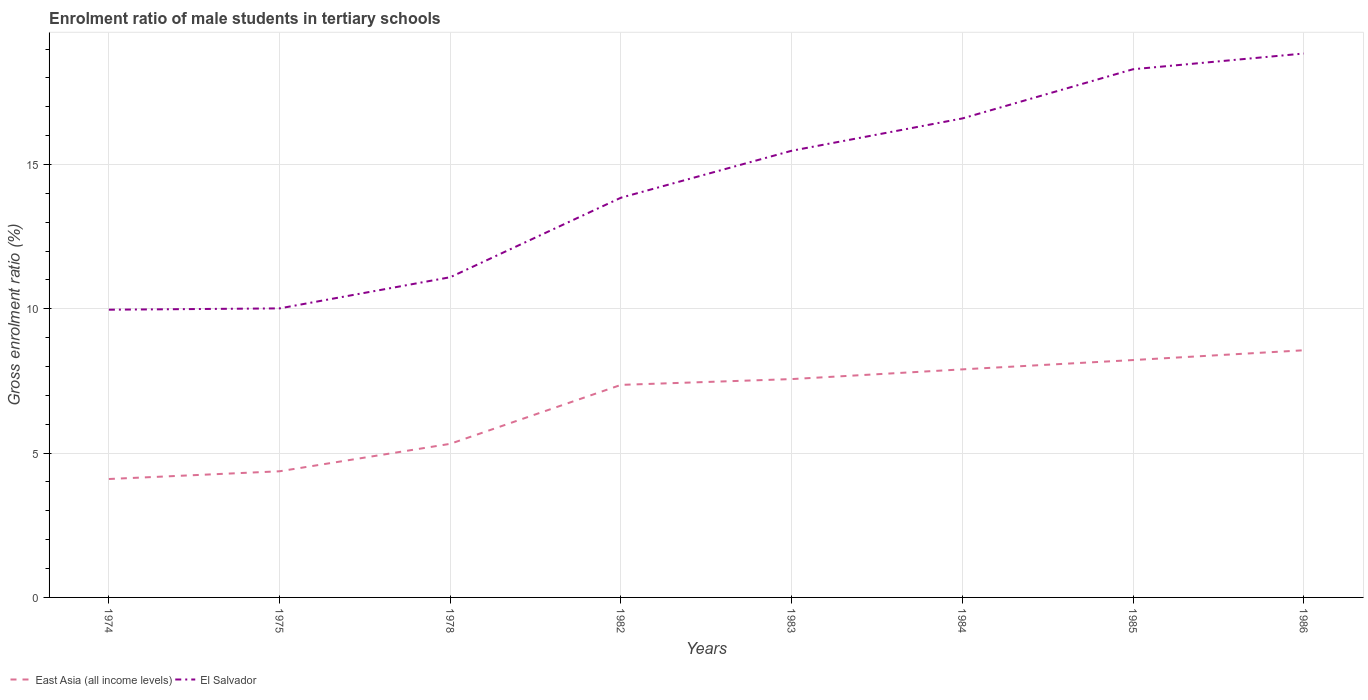Does the line corresponding to El Salvador intersect with the line corresponding to East Asia (all income levels)?
Offer a terse response. No. Across all years, what is the maximum enrolment ratio of male students in tertiary schools in El Salvador?
Make the answer very short. 9.97. In which year was the enrolment ratio of male students in tertiary schools in East Asia (all income levels) maximum?
Your answer should be very brief. 1974. What is the total enrolment ratio of male students in tertiary schools in El Salvador in the graph?
Provide a succinct answer. -2.25. What is the difference between the highest and the second highest enrolment ratio of male students in tertiary schools in East Asia (all income levels)?
Offer a very short reply. 4.46. How many lines are there?
Provide a succinct answer. 2. How many years are there in the graph?
Your response must be concise. 8. What is the difference between two consecutive major ticks on the Y-axis?
Give a very brief answer. 5. Are the values on the major ticks of Y-axis written in scientific E-notation?
Make the answer very short. No. Where does the legend appear in the graph?
Ensure brevity in your answer.  Bottom left. What is the title of the graph?
Keep it short and to the point. Enrolment ratio of male students in tertiary schools. What is the label or title of the X-axis?
Provide a short and direct response. Years. What is the label or title of the Y-axis?
Give a very brief answer. Gross enrolment ratio (%). What is the Gross enrolment ratio (%) in East Asia (all income levels) in 1974?
Offer a terse response. 4.1. What is the Gross enrolment ratio (%) in El Salvador in 1974?
Provide a succinct answer. 9.97. What is the Gross enrolment ratio (%) in East Asia (all income levels) in 1975?
Ensure brevity in your answer.  4.37. What is the Gross enrolment ratio (%) in El Salvador in 1975?
Give a very brief answer. 10.02. What is the Gross enrolment ratio (%) in East Asia (all income levels) in 1978?
Ensure brevity in your answer.  5.32. What is the Gross enrolment ratio (%) of El Salvador in 1978?
Keep it short and to the point. 11.1. What is the Gross enrolment ratio (%) in East Asia (all income levels) in 1982?
Offer a very short reply. 7.36. What is the Gross enrolment ratio (%) of El Salvador in 1982?
Provide a succinct answer. 13.85. What is the Gross enrolment ratio (%) in East Asia (all income levels) in 1983?
Give a very brief answer. 7.57. What is the Gross enrolment ratio (%) in El Salvador in 1983?
Provide a short and direct response. 15.48. What is the Gross enrolment ratio (%) in East Asia (all income levels) in 1984?
Provide a short and direct response. 7.9. What is the Gross enrolment ratio (%) in El Salvador in 1984?
Ensure brevity in your answer.  16.6. What is the Gross enrolment ratio (%) in East Asia (all income levels) in 1985?
Keep it short and to the point. 8.23. What is the Gross enrolment ratio (%) of El Salvador in 1985?
Make the answer very short. 18.3. What is the Gross enrolment ratio (%) in East Asia (all income levels) in 1986?
Provide a succinct answer. 8.56. What is the Gross enrolment ratio (%) in El Salvador in 1986?
Provide a succinct answer. 18.85. Across all years, what is the maximum Gross enrolment ratio (%) of East Asia (all income levels)?
Your answer should be very brief. 8.56. Across all years, what is the maximum Gross enrolment ratio (%) of El Salvador?
Your answer should be very brief. 18.85. Across all years, what is the minimum Gross enrolment ratio (%) of East Asia (all income levels)?
Your answer should be very brief. 4.1. Across all years, what is the minimum Gross enrolment ratio (%) of El Salvador?
Your response must be concise. 9.97. What is the total Gross enrolment ratio (%) of East Asia (all income levels) in the graph?
Provide a short and direct response. 53.42. What is the total Gross enrolment ratio (%) in El Salvador in the graph?
Make the answer very short. 114.15. What is the difference between the Gross enrolment ratio (%) of East Asia (all income levels) in 1974 and that in 1975?
Offer a terse response. -0.27. What is the difference between the Gross enrolment ratio (%) of El Salvador in 1974 and that in 1975?
Make the answer very short. -0.05. What is the difference between the Gross enrolment ratio (%) of East Asia (all income levels) in 1974 and that in 1978?
Make the answer very short. -1.22. What is the difference between the Gross enrolment ratio (%) of El Salvador in 1974 and that in 1978?
Provide a short and direct response. -1.13. What is the difference between the Gross enrolment ratio (%) in East Asia (all income levels) in 1974 and that in 1982?
Your answer should be very brief. -3.26. What is the difference between the Gross enrolment ratio (%) in El Salvador in 1974 and that in 1982?
Provide a short and direct response. -3.88. What is the difference between the Gross enrolment ratio (%) in East Asia (all income levels) in 1974 and that in 1983?
Provide a succinct answer. -3.46. What is the difference between the Gross enrolment ratio (%) of El Salvador in 1974 and that in 1983?
Your response must be concise. -5.51. What is the difference between the Gross enrolment ratio (%) in East Asia (all income levels) in 1974 and that in 1984?
Your response must be concise. -3.8. What is the difference between the Gross enrolment ratio (%) in El Salvador in 1974 and that in 1984?
Keep it short and to the point. -6.63. What is the difference between the Gross enrolment ratio (%) in East Asia (all income levels) in 1974 and that in 1985?
Give a very brief answer. -4.12. What is the difference between the Gross enrolment ratio (%) in El Salvador in 1974 and that in 1985?
Give a very brief answer. -8.33. What is the difference between the Gross enrolment ratio (%) of East Asia (all income levels) in 1974 and that in 1986?
Your response must be concise. -4.46. What is the difference between the Gross enrolment ratio (%) in El Salvador in 1974 and that in 1986?
Your answer should be very brief. -8.88. What is the difference between the Gross enrolment ratio (%) in East Asia (all income levels) in 1975 and that in 1978?
Ensure brevity in your answer.  -0.95. What is the difference between the Gross enrolment ratio (%) in El Salvador in 1975 and that in 1978?
Offer a terse response. -1.08. What is the difference between the Gross enrolment ratio (%) in East Asia (all income levels) in 1975 and that in 1982?
Your response must be concise. -2.99. What is the difference between the Gross enrolment ratio (%) of El Salvador in 1975 and that in 1982?
Ensure brevity in your answer.  -3.84. What is the difference between the Gross enrolment ratio (%) of East Asia (all income levels) in 1975 and that in 1983?
Offer a terse response. -3.19. What is the difference between the Gross enrolment ratio (%) of El Salvador in 1975 and that in 1983?
Your answer should be compact. -5.46. What is the difference between the Gross enrolment ratio (%) in East Asia (all income levels) in 1975 and that in 1984?
Your response must be concise. -3.53. What is the difference between the Gross enrolment ratio (%) in El Salvador in 1975 and that in 1984?
Give a very brief answer. -6.58. What is the difference between the Gross enrolment ratio (%) of East Asia (all income levels) in 1975 and that in 1985?
Make the answer very short. -3.85. What is the difference between the Gross enrolment ratio (%) in El Salvador in 1975 and that in 1985?
Provide a succinct answer. -8.29. What is the difference between the Gross enrolment ratio (%) of East Asia (all income levels) in 1975 and that in 1986?
Make the answer very short. -4.19. What is the difference between the Gross enrolment ratio (%) of El Salvador in 1975 and that in 1986?
Make the answer very short. -8.83. What is the difference between the Gross enrolment ratio (%) of East Asia (all income levels) in 1978 and that in 1982?
Provide a succinct answer. -2.04. What is the difference between the Gross enrolment ratio (%) of El Salvador in 1978 and that in 1982?
Offer a terse response. -2.76. What is the difference between the Gross enrolment ratio (%) in East Asia (all income levels) in 1978 and that in 1983?
Your answer should be very brief. -2.24. What is the difference between the Gross enrolment ratio (%) in El Salvador in 1978 and that in 1983?
Keep it short and to the point. -4.38. What is the difference between the Gross enrolment ratio (%) of East Asia (all income levels) in 1978 and that in 1984?
Your answer should be compact. -2.58. What is the difference between the Gross enrolment ratio (%) of El Salvador in 1978 and that in 1984?
Your answer should be very brief. -5.5. What is the difference between the Gross enrolment ratio (%) of East Asia (all income levels) in 1978 and that in 1985?
Your answer should be very brief. -2.9. What is the difference between the Gross enrolment ratio (%) of El Salvador in 1978 and that in 1985?
Your answer should be compact. -7.21. What is the difference between the Gross enrolment ratio (%) of East Asia (all income levels) in 1978 and that in 1986?
Keep it short and to the point. -3.24. What is the difference between the Gross enrolment ratio (%) in El Salvador in 1978 and that in 1986?
Make the answer very short. -7.75. What is the difference between the Gross enrolment ratio (%) of East Asia (all income levels) in 1982 and that in 1983?
Provide a short and direct response. -0.2. What is the difference between the Gross enrolment ratio (%) of El Salvador in 1982 and that in 1983?
Provide a succinct answer. -1.63. What is the difference between the Gross enrolment ratio (%) in East Asia (all income levels) in 1982 and that in 1984?
Keep it short and to the point. -0.54. What is the difference between the Gross enrolment ratio (%) of El Salvador in 1982 and that in 1984?
Make the answer very short. -2.75. What is the difference between the Gross enrolment ratio (%) in East Asia (all income levels) in 1982 and that in 1985?
Your response must be concise. -0.86. What is the difference between the Gross enrolment ratio (%) in El Salvador in 1982 and that in 1985?
Make the answer very short. -4.45. What is the difference between the Gross enrolment ratio (%) in East Asia (all income levels) in 1982 and that in 1986?
Your answer should be very brief. -1.2. What is the difference between the Gross enrolment ratio (%) in El Salvador in 1982 and that in 1986?
Keep it short and to the point. -5. What is the difference between the Gross enrolment ratio (%) of East Asia (all income levels) in 1983 and that in 1984?
Your answer should be compact. -0.34. What is the difference between the Gross enrolment ratio (%) in El Salvador in 1983 and that in 1984?
Provide a succinct answer. -1.12. What is the difference between the Gross enrolment ratio (%) of East Asia (all income levels) in 1983 and that in 1985?
Provide a short and direct response. -0.66. What is the difference between the Gross enrolment ratio (%) of El Salvador in 1983 and that in 1985?
Your answer should be very brief. -2.82. What is the difference between the Gross enrolment ratio (%) in East Asia (all income levels) in 1983 and that in 1986?
Your answer should be very brief. -1. What is the difference between the Gross enrolment ratio (%) in El Salvador in 1983 and that in 1986?
Your answer should be very brief. -3.37. What is the difference between the Gross enrolment ratio (%) in East Asia (all income levels) in 1984 and that in 1985?
Make the answer very short. -0.32. What is the difference between the Gross enrolment ratio (%) of El Salvador in 1984 and that in 1985?
Provide a succinct answer. -1.7. What is the difference between the Gross enrolment ratio (%) in East Asia (all income levels) in 1984 and that in 1986?
Offer a very short reply. -0.66. What is the difference between the Gross enrolment ratio (%) in El Salvador in 1984 and that in 1986?
Provide a succinct answer. -2.25. What is the difference between the Gross enrolment ratio (%) of East Asia (all income levels) in 1985 and that in 1986?
Ensure brevity in your answer.  -0.34. What is the difference between the Gross enrolment ratio (%) of El Salvador in 1985 and that in 1986?
Provide a succinct answer. -0.54. What is the difference between the Gross enrolment ratio (%) of East Asia (all income levels) in 1974 and the Gross enrolment ratio (%) of El Salvador in 1975?
Make the answer very short. -5.91. What is the difference between the Gross enrolment ratio (%) in East Asia (all income levels) in 1974 and the Gross enrolment ratio (%) in El Salvador in 1978?
Offer a terse response. -6.99. What is the difference between the Gross enrolment ratio (%) in East Asia (all income levels) in 1974 and the Gross enrolment ratio (%) in El Salvador in 1982?
Make the answer very short. -9.75. What is the difference between the Gross enrolment ratio (%) of East Asia (all income levels) in 1974 and the Gross enrolment ratio (%) of El Salvador in 1983?
Make the answer very short. -11.37. What is the difference between the Gross enrolment ratio (%) in East Asia (all income levels) in 1974 and the Gross enrolment ratio (%) in El Salvador in 1984?
Provide a short and direct response. -12.49. What is the difference between the Gross enrolment ratio (%) of East Asia (all income levels) in 1974 and the Gross enrolment ratio (%) of El Salvador in 1985?
Offer a terse response. -14.2. What is the difference between the Gross enrolment ratio (%) in East Asia (all income levels) in 1974 and the Gross enrolment ratio (%) in El Salvador in 1986?
Your response must be concise. -14.74. What is the difference between the Gross enrolment ratio (%) in East Asia (all income levels) in 1975 and the Gross enrolment ratio (%) in El Salvador in 1978?
Ensure brevity in your answer.  -6.72. What is the difference between the Gross enrolment ratio (%) in East Asia (all income levels) in 1975 and the Gross enrolment ratio (%) in El Salvador in 1982?
Keep it short and to the point. -9.48. What is the difference between the Gross enrolment ratio (%) of East Asia (all income levels) in 1975 and the Gross enrolment ratio (%) of El Salvador in 1983?
Offer a very short reply. -11.11. What is the difference between the Gross enrolment ratio (%) in East Asia (all income levels) in 1975 and the Gross enrolment ratio (%) in El Salvador in 1984?
Ensure brevity in your answer.  -12.23. What is the difference between the Gross enrolment ratio (%) in East Asia (all income levels) in 1975 and the Gross enrolment ratio (%) in El Salvador in 1985?
Give a very brief answer. -13.93. What is the difference between the Gross enrolment ratio (%) in East Asia (all income levels) in 1975 and the Gross enrolment ratio (%) in El Salvador in 1986?
Your answer should be very brief. -14.48. What is the difference between the Gross enrolment ratio (%) of East Asia (all income levels) in 1978 and the Gross enrolment ratio (%) of El Salvador in 1982?
Offer a terse response. -8.53. What is the difference between the Gross enrolment ratio (%) of East Asia (all income levels) in 1978 and the Gross enrolment ratio (%) of El Salvador in 1983?
Ensure brevity in your answer.  -10.15. What is the difference between the Gross enrolment ratio (%) in East Asia (all income levels) in 1978 and the Gross enrolment ratio (%) in El Salvador in 1984?
Your answer should be compact. -11.27. What is the difference between the Gross enrolment ratio (%) of East Asia (all income levels) in 1978 and the Gross enrolment ratio (%) of El Salvador in 1985?
Provide a succinct answer. -12.98. What is the difference between the Gross enrolment ratio (%) in East Asia (all income levels) in 1978 and the Gross enrolment ratio (%) in El Salvador in 1986?
Your response must be concise. -13.52. What is the difference between the Gross enrolment ratio (%) of East Asia (all income levels) in 1982 and the Gross enrolment ratio (%) of El Salvador in 1983?
Your answer should be compact. -8.11. What is the difference between the Gross enrolment ratio (%) in East Asia (all income levels) in 1982 and the Gross enrolment ratio (%) in El Salvador in 1984?
Provide a succinct answer. -9.23. What is the difference between the Gross enrolment ratio (%) of East Asia (all income levels) in 1982 and the Gross enrolment ratio (%) of El Salvador in 1985?
Give a very brief answer. -10.94. What is the difference between the Gross enrolment ratio (%) of East Asia (all income levels) in 1982 and the Gross enrolment ratio (%) of El Salvador in 1986?
Your answer should be compact. -11.48. What is the difference between the Gross enrolment ratio (%) in East Asia (all income levels) in 1983 and the Gross enrolment ratio (%) in El Salvador in 1984?
Keep it short and to the point. -9.03. What is the difference between the Gross enrolment ratio (%) of East Asia (all income levels) in 1983 and the Gross enrolment ratio (%) of El Salvador in 1985?
Provide a short and direct response. -10.74. What is the difference between the Gross enrolment ratio (%) of East Asia (all income levels) in 1983 and the Gross enrolment ratio (%) of El Salvador in 1986?
Keep it short and to the point. -11.28. What is the difference between the Gross enrolment ratio (%) of East Asia (all income levels) in 1984 and the Gross enrolment ratio (%) of El Salvador in 1985?
Keep it short and to the point. -10.4. What is the difference between the Gross enrolment ratio (%) in East Asia (all income levels) in 1984 and the Gross enrolment ratio (%) in El Salvador in 1986?
Your answer should be compact. -10.94. What is the difference between the Gross enrolment ratio (%) in East Asia (all income levels) in 1985 and the Gross enrolment ratio (%) in El Salvador in 1986?
Provide a succinct answer. -10.62. What is the average Gross enrolment ratio (%) of East Asia (all income levels) per year?
Offer a terse response. 6.68. What is the average Gross enrolment ratio (%) of El Salvador per year?
Give a very brief answer. 14.27. In the year 1974, what is the difference between the Gross enrolment ratio (%) in East Asia (all income levels) and Gross enrolment ratio (%) in El Salvador?
Give a very brief answer. -5.87. In the year 1975, what is the difference between the Gross enrolment ratio (%) of East Asia (all income levels) and Gross enrolment ratio (%) of El Salvador?
Keep it short and to the point. -5.64. In the year 1978, what is the difference between the Gross enrolment ratio (%) of East Asia (all income levels) and Gross enrolment ratio (%) of El Salvador?
Provide a short and direct response. -5.77. In the year 1982, what is the difference between the Gross enrolment ratio (%) of East Asia (all income levels) and Gross enrolment ratio (%) of El Salvador?
Your answer should be very brief. -6.49. In the year 1983, what is the difference between the Gross enrolment ratio (%) of East Asia (all income levels) and Gross enrolment ratio (%) of El Salvador?
Ensure brevity in your answer.  -7.91. In the year 1984, what is the difference between the Gross enrolment ratio (%) in East Asia (all income levels) and Gross enrolment ratio (%) in El Salvador?
Provide a short and direct response. -8.69. In the year 1985, what is the difference between the Gross enrolment ratio (%) in East Asia (all income levels) and Gross enrolment ratio (%) in El Salvador?
Offer a very short reply. -10.08. In the year 1986, what is the difference between the Gross enrolment ratio (%) of East Asia (all income levels) and Gross enrolment ratio (%) of El Salvador?
Offer a terse response. -10.28. What is the ratio of the Gross enrolment ratio (%) in East Asia (all income levels) in 1974 to that in 1975?
Offer a very short reply. 0.94. What is the ratio of the Gross enrolment ratio (%) in East Asia (all income levels) in 1974 to that in 1978?
Give a very brief answer. 0.77. What is the ratio of the Gross enrolment ratio (%) in El Salvador in 1974 to that in 1978?
Offer a terse response. 0.9. What is the ratio of the Gross enrolment ratio (%) of East Asia (all income levels) in 1974 to that in 1982?
Your answer should be very brief. 0.56. What is the ratio of the Gross enrolment ratio (%) of El Salvador in 1974 to that in 1982?
Provide a succinct answer. 0.72. What is the ratio of the Gross enrolment ratio (%) in East Asia (all income levels) in 1974 to that in 1983?
Ensure brevity in your answer.  0.54. What is the ratio of the Gross enrolment ratio (%) of El Salvador in 1974 to that in 1983?
Ensure brevity in your answer.  0.64. What is the ratio of the Gross enrolment ratio (%) in East Asia (all income levels) in 1974 to that in 1984?
Keep it short and to the point. 0.52. What is the ratio of the Gross enrolment ratio (%) of El Salvador in 1974 to that in 1984?
Provide a succinct answer. 0.6. What is the ratio of the Gross enrolment ratio (%) in East Asia (all income levels) in 1974 to that in 1985?
Provide a succinct answer. 0.5. What is the ratio of the Gross enrolment ratio (%) of El Salvador in 1974 to that in 1985?
Your answer should be compact. 0.54. What is the ratio of the Gross enrolment ratio (%) in East Asia (all income levels) in 1974 to that in 1986?
Provide a short and direct response. 0.48. What is the ratio of the Gross enrolment ratio (%) in El Salvador in 1974 to that in 1986?
Offer a terse response. 0.53. What is the ratio of the Gross enrolment ratio (%) of East Asia (all income levels) in 1975 to that in 1978?
Provide a succinct answer. 0.82. What is the ratio of the Gross enrolment ratio (%) in El Salvador in 1975 to that in 1978?
Give a very brief answer. 0.9. What is the ratio of the Gross enrolment ratio (%) of East Asia (all income levels) in 1975 to that in 1982?
Provide a succinct answer. 0.59. What is the ratio of the Gross enrolment ratio (%) of El Salvador in 1975 to that in 1982?
Your answer should be compact. 0.72. What is the ratio of the Gross enrolment ratio (%) in East Asia (all income levels) in 1975 to that in 1983?
Ensure brevity in your answer.  0.58. What is the ratio of the Gross enrolment ratio (%) of El Salvador in 1975 to that in 1983?
Ensure brevity in your answer.  0.65. What is the ratio of the Gross enrolment ratio (%) of East Asia (all income levels) in 1975 to that in 1984?
Your response must be concise. 0.55. What is the ratio of the Gross enrolment ratio (%) of El Salvador in 1975 to that in 1984?
Offer a very short reply. 0.6. What is the ratio of the Gross enrolment ratio (%) of East Asia (all income levels) in 1975 to that in 1985?
Give a very brief answer. 0.53. What is the ratio of the Gross enrolment ratio (%) of El Salvador in 1975 to that in 1985?
Give a very brief answer. 0.55. What is the ratio of the Gross enrolment ratio (%) in East Asia (all income levels) in 1975 to that in 1986?
Make the answer very short. 0.51. What is the ratio of the Gross enrolment ratio (%) of El Salvador in 1975 to that in 1986?
Keep it short and to the point. 0.53. What is the ratio of the Gross enrolment ratio (%) of East Asia (all income levels) in 1978 to that in 1982?
Ensure brevity in your answer.  0.72. What is the ratio of the Gross enrolment ratio (%) of El Salvador in 1978 to that in 1982?
Provide a succinct answer. 0.8. What is the ratio of the Gross enrolment ratio (%) of East Asia (all income levels) in 1978 to that in 1983?
Your answer should be compact. 0.7. What is the ratio of the Gross enrolment ratio (%) of El Salvador in 1978 to that in 1983?
Give a very brief answer. 0.72. What is the ratio of the Gross enrolment ratio (%) of East Asia (all income levels) in 1978 to that in 1984?
Provide a short and direct response. 0.67. What is the ratio of the Gross enrolment ratio (%) of El Salvador in 1978 to that in 1984?
Give a very brief answer. 0.67. What is the ratio of the Gross enrolment ratio (%) of East Asia (all income levels) in 1978 to that in 1985?
Keep it short and to the point. 0.65. What is the ratio of the Gross enrolment ratio (%) of El Salvador in 1978 to that in 1985?
Offer a terse response. 0.61. What is the ratio of the Gross enrolment ratio (%) in East Asia (all income levels) in 1978 to that in 1986?
Make the answer very short. 0.62. What is the ratio of the Gross enrolment ratio (%) of El Salvador in 1978 to that in 1986?
Keep it short and to the point. 0.59. What is the ratio of the Gross enrolment ratio (%) of East Asia (all income levels) in 1982 to that in 1983?
Keep it short and to the point. 0.97. What is the ratio of the Gross enrolment ratio (%) in El Salvador in 1982 to that in 1983?
Offer a terse response. 0.89. What is the ratio of the Gross enrolment ratio (%) of East Asia (all income levels) in 1982 to that in 1984?
Your response must be concise. 0.93. What is the ratio of the Gross enrolment ratio (%) of El Salvador in 1982 to that in 1984?
Offer a very short reply. 0.83. What is the ratio of the Gross enrolment ratio (%) in East Asia (all income levels) in 1982 to that in 1985?
Provide a short and direct response. 0.9. What is the ratio of the Gross enrolment ratio (%) in El Salvador in 1982 to that in 1985?
Provide a short and direct response. 0.76. What is the ratio of the Gross enrolment ratio (%) in East Asia (all income levels) in 1982 to that in 1986?
Offer a very short reply. 0.86. What is the ratio of the Gross enrolment ratio (%) of El Salvador in 1982 to that in 1986?
Provide a short and direct response. 0.73. What is the ratio of the Gross enrolment ratio (%) of East Asia (all income levels) in 1983 to that in 1984?
Ensure brevity in your answer.  0.96. What is the ratio of the Gross enrolment ratio (%) of El Salvador in 1983 to that in 1984?
Give a very brief answer. 0.93. What is the ratio of the Gross enrolment ratio (%) of East Asia (all income levels) in 1983 to that in 1985?
Ensure brevity in your answer.  0.92. What is the ratio of the Gross enrolment ratio (%) in El Salvador in 1983 to that in 1985?
Ensure brevity in your answer.  0.85. What is the ratio of the Gross enrolment ratio (%) in East Asia (all income levels) in 1983 to that in 1986?
Your answer should be very brief. 0.88. What is the ratio of the Gross enrolment ratio (%) of El Salvador in 1983 to that in 1986?
Your answer should be very brief. 0.82. What is the ratio of the Gross enrolment ratio (%) of East Asia (all income levels) in 1984 to that in 1985?
Ensure brevity in your answer.  0.96. What is the ratio of the Gross enrolment ratio (%) of El Salvador in 1984 to that in 1985?
Give a very brief answer. 0.91. What is the ratio of the Gross enrolment ratio (%) in East Asia (all income levels) in 1984 to that in 1986?
Your answer should be very brief. 0.92. What is the ratio of the Gross enrolment ratio (%) of El Salvador in 1984 to that in 1986?
Keep it short and to the point. 0.88. What is the ratio of the Gross enrolment ratio (%) in East Asia (all income levels) in 1985 to that in 1986?
Your answer should be compact. 0.96. What is the ratio of the Gross enrolment ratio (%) of El Salvador in 1985 to that in 1986?
Make the answer very short. 0.97. What is the difference between the highest and the second highest Gross enrolment ratio (%) of East Asia (all income levels)?
Give a very brief answer. 0.34. What is the difference between the highest and the second highest Gross enrolment ratio (%) in El Salvador?
Your answer should be very brief. 0.54. What is the difference between the highest and the lowest Gross enrolment ratio (%) of East Asia (all income levels)?
Keep it short and to the point. 4.46. What is the difference between the highest and the lowest Gross enrolment ratio (%) in El Salvador?
Provide a succinct answer. 8.88. 